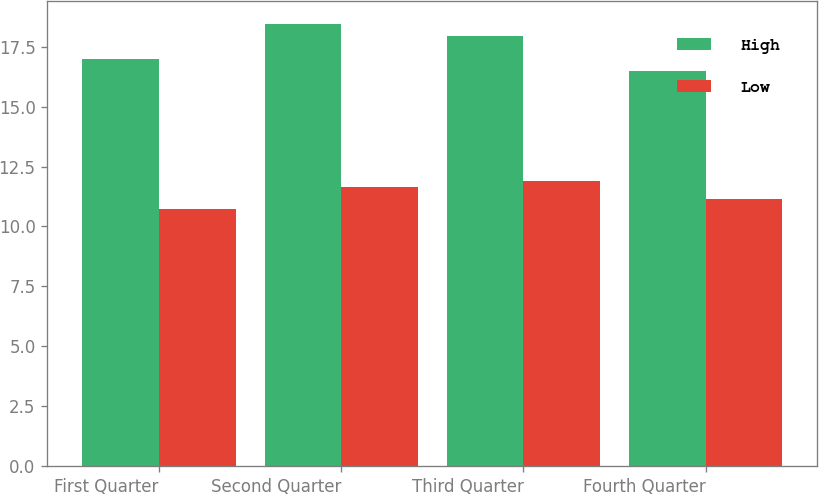Convert chart to OTSL. <chart><loc_0><loc_0><loc_500><loc_500><stacked_bar_chart><ecel><fcel>First Quarter<fcel>Second Quarter<fcel>Third Quarter<fcel>Fourth Quarter<nl><fcel>High<fcel>16.97<fcel>18.47<fcel>17.95<fcel>16.5<nl><fcel>Low<fcel>10.74<fcel>11.65<fcel>11.9<fcel>11.15<nl></chart> 